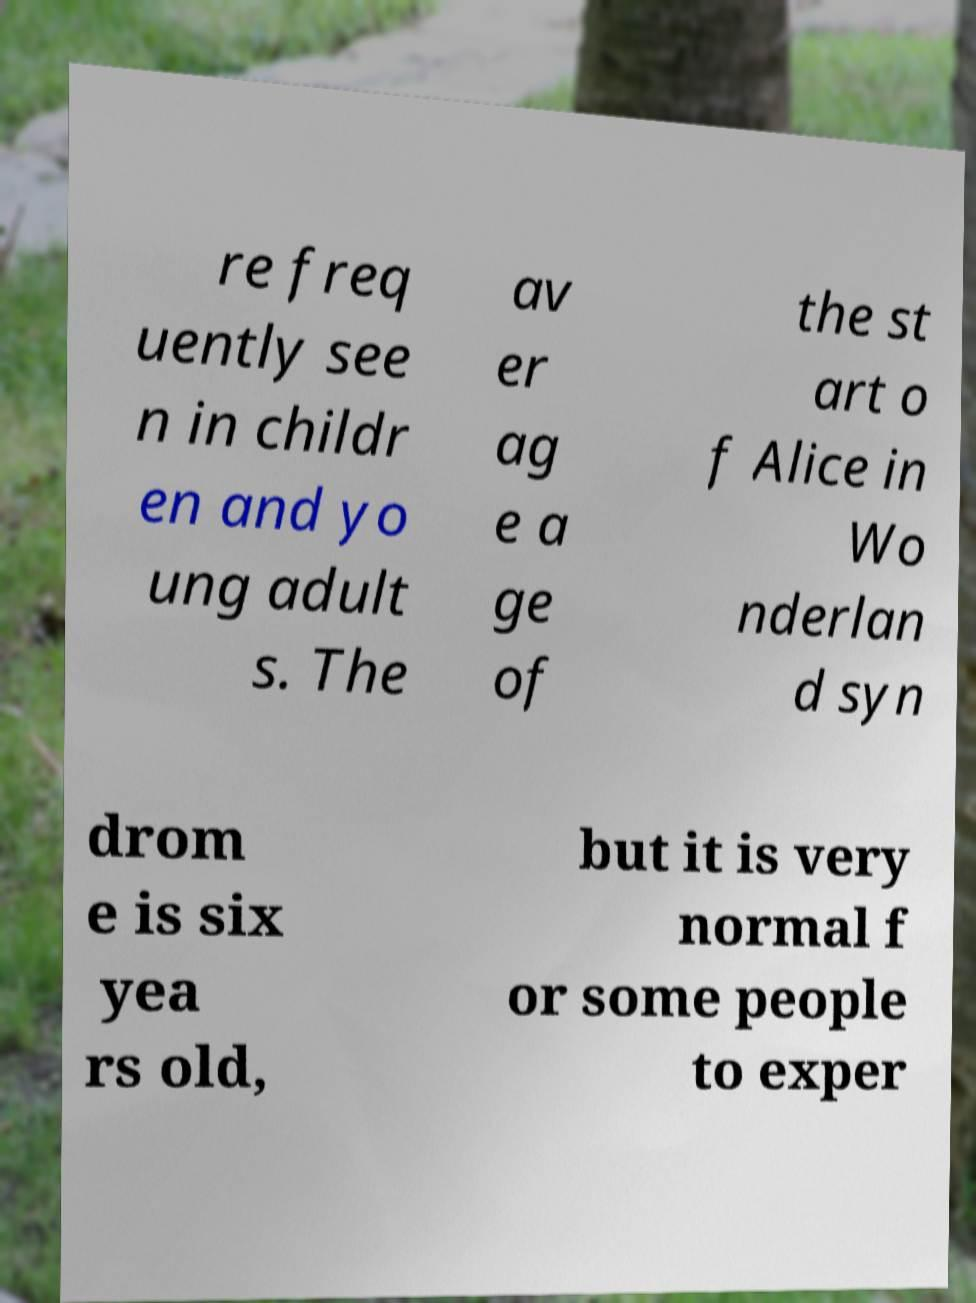Please identify and transcribe the text found in this image. re freq uently see n in childr en and yo ung adult s. The av er ag e a ge of the st art o f Alice in Wo nderlan d syn drom e is six yea rs old, but it is very normal f or some people to exper 